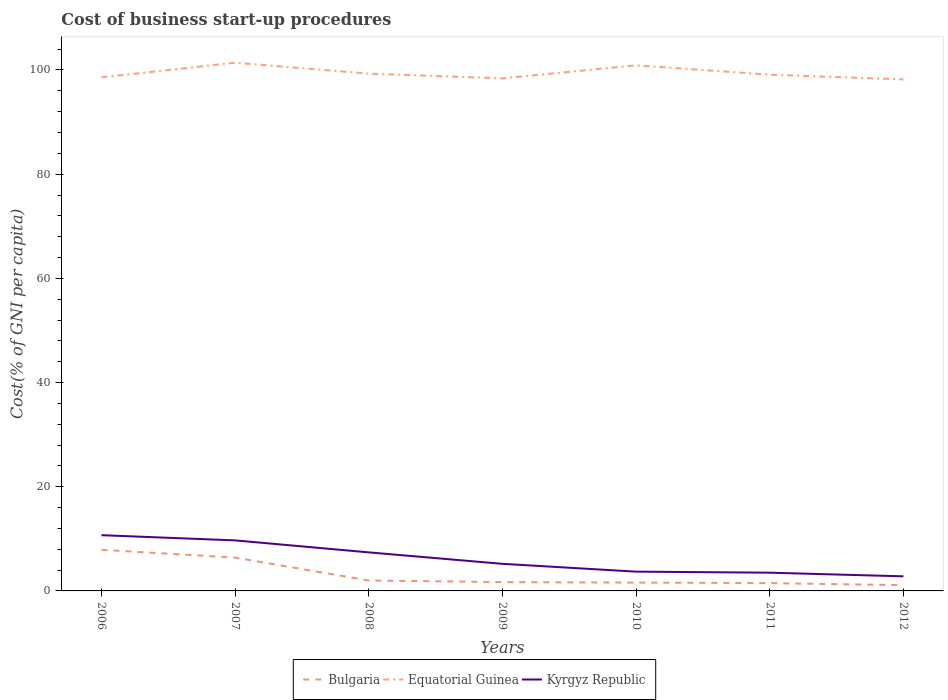How many different coloured lines are there?
Ensure brevity in your answer.  3. Across all years, what is the maximum cost of business start-up procedures in Equatorial Guinea?
Make the answer very short. 98.2. In which year was the cost of business start-up procedures in Kyrgyz Republic maximum?
Keep it short and to the point. 2012. What is the total cost of business start-up procedures in Kyrgyz Republic in the graph?
Give a very brief answer. 1.7. What is the difference between the highest and the second highest cost of business start-up procedures in Bulgaria?
Provide a short and direct response. 6.8. What is the difference between the highest and the lowest cost of business start-up procedures in Equatorial Guinea?
Make the answer very short. 2. Are the values on the major ticks of Y-axis written in scientific E-notation?
Give a very brief answer. No. Where does the legend appear in the graph?
Your answer should be compact. Bottom center. How many legend labels are there?
Offer a terse response. 3. How are the legend labels stacked?
Give a very brief answer. Horizontal. What is the title of the graph?
Keep it short and to the point. Cost of business start-up procedures. Does "Italy" appear as one of the legend labels in the graph?
Your answer should be compact. No. What is the label or title of the X-axis?
Keep it short and to the point. Years. What is the label or title of the Y-axis?
Give a very brief answer. Cost(% of GNI per capita). What is the Cost(% of GNI per capita) in Bulgaria in 2006?
Ensure brevity in your answer.  7.9. What is the Cost(% of GNI per capita) in Equatorial Guinea in 2006?
Keep it short and to the point. 98.6. What is the Cost(% of GNI per capita) in Kyrgyz Republic in 2006?
Keep it short and to the point. 10.7. What is the Cost(% of GNI per capita) of Bulgaria in 2007?
Keep it short and to the point. 6.4. What is the Cost(% of GNI per capita) of Equatorial Guinea in 2007?
Ensure brevity in your answer.  101.4. What is the Cost(% of GNI per capita) of Kyrgyz Republic in 2007?
Offer a terse response. 9.7. What is the Cost(% of GNI per capita) of Bulgaria in 2008?
Keep it short and to the point. 2. What is the Cost(% of GNI per capita) of Equatorial Guinea in 2008?
Make the answer very short. 99.3. What is the Cost(% of GNI per capita) of Bulgaria in 2009?
Your answer should be very brief. 1.7. What is the Cost(% of GNI per capita) of Equatorial Guinea in 2009?
Make the answer very short. 98.4. What is the Cost(% of GNI per capita) of Bulgaria in 2010?
Offer a terse response. 1.6. What is the Cost(% of GNI per capita) of Equatorial Guinea in 2010?
Your answer should be compact. 100.9. What is the Cost(% of GNI per capita) of Equatorial Guinea in 2011?
Your answer should be compact. 99.1. What is the Cost(% of GNI per capita) of Equatorial Guinea in 2012?
Ensure brevity in your answer.  98.2. What is the Cost(% of GNI per capita) in Kyrgyz Republic in 2012?
Provide a succinct answer. 2.8. Across all years, what is the maximum Cost(% of GNI per capita) in Bulgaria?
Provide a succinct answer. 7.9. Across all years, what is the maximum Cost(% of GNI per capita) in Equatorial Guinea?
Offer a very short reply. 101.4. Across all years, what is the maximum Cost(% of GNI per capita) in Kyrgyz Republic?
Ensure brevity in your answer.  10.7. Across all years, what is the minimum Cost(% of GNI per capita) of Equatorial Guinea?
Your answer should be compact. 98.2. What is the total Cost(% of GNI per capita) in Equatorial Guinea in the graph?
Your response must be concise. 695.9. What is the total Cost(% of GNI per capita) in Kyrgyz Republic in the graph?
Ensure brevity in your answer.  43. What is the difference between the Cost(% of GNI per capita) of Equatorial Guinea in 2006 and that in 2007?
Ensure brevity in your answer.  -2.8. What is the difference between the Cost(% of GNI per capita) in Bulgaria in 2006 and that in 2008?
Provide a short and direct response. 5.9. What is the difference between the Cost(% of GNI per capita) in Equatorial Guinea in 2006 and that in 2008?
Ensure brevity in your answer.  -0.7. What is the difference between the Cost(% of GNI per capita) of Kyrgyz Republic in 2006 and that in 2008?
Your answer should be very brief. 3.3. What is the difference between the Cost(% of GNI per capita) of Bulgaria in 2006 and that in 2009?
Offer a terse response. 6.2. What is the difference between the Cost(% of GNI per capita) in Bulgaria in 2006 and that in 2010?
Provide a short and direct response. 6.3. What is the difference between the Cost(% of GNI per capita) in Equatorial Guinea in 2006 and that in 2010?
Offer a terse response. -2.3. What is the difference between the Cost(% of GNI per capita) of Bulgaria in 2006 and that in 2011?
Your answer should be compact. 6.4. What is the difference between the Cost(% of GNI per capita) of Kyrgyz Republic in 2006 and that in 2011?
Provide a succinct answer. 7.2. What is the difference between the Cost(% of GNI per capita) in Bulgaria in 2006 and that in 2012?
Ensure brevity in your answer.  6.8. What is the difference between the Cost(% of GNI per capita) of Equatorial Guinea in 2006 and that in 2012?
Make the answer very short. 0.4. What is the difference between the Cost(% of GNI per capita) of Bulgaria in 2007 and that in 2009?
Provide a short and direct response. 4.7. What is the difference between the Cost(% of GNI per capita) of Equatorial Guinea in 2007 and that in 2009?
Keep it short and to the point. 3. What is the difference between the Cost(% of GNI per capita) in Kyrgyz Republic in 2007 and that in 2009?
Keep it short and to the point. 4.5. What is the difference between the Cost(% of GNI per capita) of Equatorial Guinea in 2007 and that in 2010?
Keep it short and to the point. 0.5. What is the difference between the Cost(% of GNI per capita) in Kyrgyz Republic in 2007 and that in 2010?
Ensure brevity in your answer.  6. What is the difference between the Cost(% of GNI per capita) of Bulgaria in 2008 and that in 2009?
Your answer should be compact. 0.3. What is the difference between the Cost(% of GNI per capita) in Equatorial Guinea in 2008 and that in 2010?
Give a very brief answer. -1.6. What is the difference between the Cost(% of GNI per capita) in Kyrgyz Republic in 2008 and that in 2010?
Your answer should be very brief. 3.7. What is the difference between the Cost(% of GNI per capita) in Equatorial Guinea in 2008 and that in 2012?
Provide a short and direct response. 1.1. What is the difference between the Cost(% of GNI per capita) of Equatorial Guinea in 2009 and that in 2010?
Your answer should be compact. -2.5. What is the difference between the Cost(% of GNI per capita) in Bulgaria in 2009 and that in 2011?
Give a very brief answer. 0.2. What is the difference between the Cost(% of GNI per capita) of Equatorial Guinea in 2009 and that in 2012?
Your answer should be compact. 0.2. What is the difference between the Cost(% of GNI per capita) of Equatorial Guinea in 2010 and that in 2011?
Provide a short and direct response. 1.8. What is the difference between the Cost(% of GNI per capita) of Bulgaria in 2010 and that in 2012?
Give a very brief answer. 0.5. What is the difference between the Cost(% of GNI per capita) in Equatorial Guinea in 2010 and that in 2012?
Keep it short and to the point. 2.7. What is the difference between the Cost(% of GNI per capita) in Kyrgyz Republic in 2011 and that in 2012?
Make the answer very short. 0.7. What is the difference between the Cost(% of GNI per capita) of Bulgaria in 2006 and the Cost(% of GNI per capita) of Equatorial Guinea in 2007?
Your answer should be very brief. -93.5. What is the difference between the Cost(% of GNI per capita) of Bulgaria in 2006 and the Cost(% of GNI per capita) of Kyrgyz Republic in 2007?
Make the answer very short. -1.8. What is the difference between the Cost(% of GNI per capita) of Equatorial Guinea in 2006 and the Cost(% of GNI per capita) of Kyrgyz Republic in 2007?
Offer a terse response. 88.9. What is the difference between the Cost(% of GNI per capita) of Bulgaria in 2006 and the Cost(% of GNI per capita) of Equatorial Guinea in 2008?
Provide a short and direct response. -91.4. What is the difference between the Cost(% of GNI per capita) in Bulgaria in 2006 and the Cost(% of GNI per capita) in Kyrgyz Republic in 2008?
Make the answer very short. 0.5. What is the difference between the Cost(% of GNI per capita) in Equatorial Guinea in 2006 and the Cost(% of GNI per capita) in Kyrgyz Republic in 2008?
Offer a very short reply. 91.2. What is the difference between the Cost(% of GNI per capita) in Bulgaria in 2006 and the Cost(% of GNI per capita) in Equatorial Guinea in 2009?
Provide a short and direct response. -90.5. What is the difference between the Cost(% of GNI per capita) of Equatorial Guinea in 2006 and the Cost(% of GNI per capita) of Kyrgyz Republic in 2009?
Your response must be concise. 93.4. What is the difference between the Cost(% of GNI per capita) of Bulgaria in 2006 and the Cost(% of GNI per capita) of Equatorial Guinea in 2010?
Provide a succinct answer. -93. What is the difference between the Cost(% of GNI per capita) of Bulgaria in 2006 and the Cost(% of GNI per capita) of Kyrgyz Republic in 2010?
Keep it short and to the point. 4.2. What is the difference between the Cost(% of GNI per capita) of Equatorial Guinea in 2006 and the Cost(% of GNI per capita) of Kyrgyz Republic in 2010?
Offer a terse response. 94.9. What is the difference between the Cost(% of GNI per capita) in Bulgaria in 2006 and the Cost(% of GNI per capita) in Equatorial Guinea in 2011?
Your answer should be compact. -91.2. What is the difference between the Cost(% of GNI per capita) of Bulgaria in 2006 and the Cost(% of GNI per capita) of Kyrgyz Republic in 2011?
Provide a short and direct response. 4.4. What is the difference between the Cost(% of GNI per capita) of Equatorial Guinea in 2006 and the Cost(% of GNI per capita) of Kyrgyz Republic in 2011?
Your answer should be compact. 95.1. What is the difference between the Cost(% of GNI per capita) in Bulgaria in 2006 and the Cost(% of GNI per capita) in Equatorial Guinea in 2012?
Provide a succinct answer. -90.3. What is the difference between the Cost(% of GNI per capita) in Bulgaria in 2006 and the Cost(% of GNI per capita) in Kyrgyz Republic in 2012?
Make the answer very short. 5.1. What is the difference between the Cost(% of GNI per capita) of Equatorial Guinea in 2006 and the Cost(% of GNI per capita) of Kyrgyz Republic in 2012?
Ensure brevity in your answer.  95.8. What is the difference between the Cost(% of GNI per capita) in Bulgaria in 2007 and the Cost(% of GNI per capita) in Equatorial Guinea in 2008?
Your response must be concise. -92.9. What is the difference between the Cost(% of GNI per capita) of Equatorial Guinea in 2007 and the Cost(% of GNI per capita) of Kyrgyz Republic in 2008?
Offer a terse response. 94. What is the difference between the Cost(% of GNI per capita) in Bulgaria in 2007 and the Cost(% of GNI per capita) in Equatorial Guinea in 2009?
Your answer should be compact. -92. What is the difference between the Cost(% of GNI per capita) of Bulgaria in 2007 and the Cost(% of GNI per capita) of Kyrgyz Republic in 2009?
Offer a terse response. 1.2. What is the difference between the Cost(% of GNI per capita) in Equatorial Guinea in 2007 and the Cost(% of GNI per capita) in Kyrgyz Republic in 2009?
Provide a succinct answer. 96.2. What is the difference between the Cost(% of GNI per capita) in Bulgaria in 2007 and the Cost(% of GNI per capita) in Equatorial Guinea in 2010?
Give a very brief answer. -94.5. What is the difference between the Cost(% of GNI per capita) of Equatorial Guinea in 2007 and the Cost(% of GNI per capita) of Kyrgyz Republic in 2010?
Your answer should be compact. 97.7. What is the difference between the Cost(% of GNI per capita) in Bulgaria in 2007 and the Cost(% of GNI per capita) in Equatorial Guinea in 2011?
Your response must be concise. -92.7. What is the difference between the Cost(% of GNI per capita) of Bulgaria in 2007 and the Cost(% of GNI per capita) of Kyrgyz Republic in 2011?
Keep it short and to the point. 2.9. What is the difference between the Cost(% of GNI per capita) in Equatorial Guinea in 2007 and the Cost(% of GNI per capita) in Kyrgyz Republic in 2011?
Give a very brief answer. 97.9. What is the difference between the Cost(% of GNI per capita) of Bulgaria in 2007 and the Cost(% of GNI per capita) of Equatorial Guinea in 2012?
Provide a short and direct response. -91.8. What is the difference between the Cost(% of GNI per capita) in Equatorial Guinea in 2007 and the Cost(% of GNI per capita) in Kyrgyz Republic in 2012?
Ensure brevity in your answer.  98.6. What is the difference between the Cost(% of GNI per capita) in Bulgaria in 2008 and the Cost(% of GNI per capita) in Equatorial Guinea in 2009?
Provide a succinct answer. -96.4. What is the difference between the Cost(% of GNI per capita) in Equatorial Guinea in 2008 and the Cost(% of GNI per capita) in Kyrgyz Republic in 2009?
Make the answer very short. 94.1. What is the difference between the Cost(% of GNI per capita) of Bulgaria in 2008 and the Cost(% of GNI per capita) of Equatorial Guinea in 2010?
Make the answer very short. -98.9. What is the difference between the Cost(% of GNI per capita) of Bulgaria in 2008 and the Cost(% of GNI per capita) of Kyrgyz Republic in 2010?
Offer a very short reply. -1.7. What is the difference between the Cost(% of GNI per capita) of Equatorial Guinea in 2008 and the Cost(% of GNI per capita) of Kyrgyz Republic in 2010?
Your response must be concise. 95.6. What is the difference between the Cost(% of GNI per capita) in Bulgaria in 2008 and the Cost(% of GNI per capita) in Equatorial Guinea in 2011?
Provide a succinct answer. -97.1. What is the difference between the Cost(% of GNI per capita) in Bulgaria in 2008 and the Cost(% of GNI per capita) in Kyrgyz Republic in 2011?
Keep it short and to the point. -1.5. What is the difference between the Cost(% of GNI per capita) of Equatorial Guinea in 2008 and the Cost(% of GNI per capita) of Kyrgyz Republic in 2011?
Make the answer very short. 95.8. What is the difference between the Cost(% of GNI per capita) in Bulgaria in 2008 and the Cost(% of GNI per capita) in Equatorial Guinea in 2012?
Your response must be concise. -96.2. What is the difference between the Cost(% of GNI per capita) of Bulgaria in 2008 and the Cost(% of GNI per capita) of Kyrgyz Republic in 2012?
Make the answer very short. -0.8. What is the difference between the Cost(% of GNI per capita) of Equatorial Guinea in 2008 and the Cost(% of GNI per capita) of Kyrgyz Republic in 2012?
Offer a terse response. 96.5. What is the difference between the Cost(% of GNI per capita) in Bulgaria in 2009 and the Cost(% of GNI per capita) in Equatorial Guinea in 2010?
Ensure brevity in your answer.  -99.2. What is the difference between the Cost(% of GNI per capita) of Bulgaria in 2009 and the Cost(% of GNI per capita) of Kyrgyz Republic in 2010?
Your answer should be compact. -2. What is the difference between the Cost(% of GNI per capita) in Equatorial Guinea in 2009 and the Cost(% of GNI per capita) in Kyrgyz Republic in 2010?
Provide a short and direct response. 94.7. What is the difference between the Cost(% of GNI per capita) in Bulgaria in 2009 and the Cost(% of GNI per capita) in Equatorial Guinea in 2011?
Your answer should be very brief. -97.4. What is the difference between the Cost(% of GNI per capita) of Bulgaria in 2009 and the Cost(% of GNI per capita) of Kyrgyz Republic in 2011?
Your answer should be compact. -1.8. What is the difference between the Cost(% of GNI per capita) in Equatorial Guinea in 2009 and the Cost(% of GNI per capita) in Kyrgyz Republic in 2011?
Provide a succinct answer. 94.9. What is the difference between the Cost(% of GNI per capita) of Bulgaria in 2009 and the Cost(% of GNI per capita) of Equatorial Guinea in 2012?
Your response must be concise. -96.5. What is the difference between the Cost(% of GNI per capita) of Bulgaria in 2009 and the Cost(% of GNI per capita) of Kyrgyz Republic in 2012?
Your answer should be very brief. -1.1. What is the difference between the Cost(% of GNI per capita) in Equatorial Guinea in 2009 and the Cost(% of GNI per capita) in Kyrgyz Republic in 2012?
Your response must be concise. 95.6. What is the difference between the Cost(% of GNI per capita) in Bulgaria in 2010 and the Cost(% of GNI per capita) in Equatorial Guinea in 2011?
Offer a very short reply. -97.5. What is the difference between the Cost(% of GNI per capita) of Bulgaria in 2010 and the Cost(% of GNI per capita) of Kyrgyz Republic in 2011?
Make the answer very short. -1.9. What is the difference between the Cost(% of GNI per capita) of Equatorial Guinea in 2010 and the Cost(% of GNI per capita) of Kyrgyz Republic in 2011?
Your answer should be very brief. 97.4. What is the difference between the Cost(% of GNI per capita) in Bulgaria in 2010 and the Cost(% of GNI per capita) in Equatorial Guinea in 2012?
Your answer should be compact. -96.6. What is the difference between the Cost(% of GNI per capita) in Bulgaria in 2010 and the Cost(% of GNI per capita) in Kyrgyz Republic in 2012?
Make the answer very short. -1.2. What is the difference between the Cost(% of GNI per capita) in Equatorial Guinea in 2010 and the Cost(% of GNI per capita) in Kyrgyz Republic in 2012?
Your answer should be compact. 98.1. What is the difference between the Cost(% of GNI per capita) in Bulgaria in 2011 and the Cost(% of GNI per capita) in Equatorial Guinea in 2012?
Your response must be concise. -96.7. What is the difference between the Cost(% of GNI per capita) in Bulgaria in 2011 and the Cost(% of GNI per capita) in Kyrgyz Republic in 2012?
Make the answer very short. -1.3. What is the difference between the Cost(% of GNI per capita) in Equatorial Guinea in 2011 and the Cost(% of GNI per capita) in Kyrgyz Republic in 2012?
Give a very brief answer. 96.3. What is the average Cost(% of GNI per capita) in Bulgaria per year?
Provide a succinct answer. 3.17. What is the average Cost(% of GNI per capita) of Equatorial Guinea per year?
Offer a terse response. 99.41. What is the average Cost(% of GNI per capita) of Kyrgyz Republic per year?
Your answer should be very brief. 6.14. In the year 2006, what is the difference between the Cost(% of GNI per capita) of Bulgaria and Cost(% of GNI per capita) of Equatorial Guinea?
Your response must be concise. -90.7. In the year 2006, what is the difference between the Cost(% of GNI per capita) in Bulgaria and Cost(% of GNI per capita) in Kyrgyz Republic?
Make the answer very short. -2.8. In the year 2006, what is the difference between the Cost(% of GNI per capita) of Equatorial Guinea and Cost(% of GNI per capita) of Kyrgyz Republic?
Keep it short and to the point. 87.9. In the year 2007, what is the difference between the Cost(% of GNI per capita) in Bulgaria and Cost(% of GNI per capita) in Equatorial Guinea?
Keep it short and to the point. -95. In the year 2007, what is the difference between the Cost(% of GNI per capita) in Bulgaria and Cost(% of GNI per capita) in Kyrgyz Republic?
Offer a terse response. -3.3. In the year 2007, what is the difference between the Cost(% of GNI per capita) in Equatorial Guinea and Cost(% of GNI per capita) in Kyrgyz Republic?
Offer a very short reply. 91.7. In the year 2008, what is the difference between the Cost(% of GNI per capita) in Bulgaria and Cost(% of GNI per capita) in Equatorial Guinea?
Ensure brevity in your answer.  -97.3. In the year 2008, what is the difference between the Cost(% of GNI per capita) in Equatorial Guinea and Cost(% of GNI per capita) in Kyrgyz Republic?
Ensure brevity in your answer.  91.9. In the year 2009, what is the difference between the Cost(% of GNI per capita) in Bulgaria and Cost(% of GNI per capita) in Equatorial Guinea?
Your answer should be compact. -96.7. In the year 2009, what is the difference between the Cost(% of GNI per capita) of Equatorial Guinea and Cost(% of GNI per capita) of Kyrgyz Republic?
Provide a succinct answer. 93.2. In the year 2010, what is the difference between the Cost(% of GNI per capita) in Bulgaria and Cost(% of GNI per capita) in Equatorial Guinea?
Your answer should be very brief. -99.3. In the year 2010, what is the difference between the Cost(% of GNI per capita) in Bulgaria and Cost(% of GNI per capita) in Kyrgyz Republic?
Your answer should be very brief. -2.1. In the year 2010, what is the difference between the Cost(% of GNI per capita) in Equatorial Guinea and Cost(% of GNI per capita) in Kyrgyz Republic?
Provide a short and direct response. 97.2. In the year 2011, what is the difference between the Cost(% of GNI per capita) of Bulgaria and Cost(% of GNI per capita) of Equatorial Guinea?
Give a very brief answer. -97.6. In the year 2011, what is the difference between the Cost(% of GNI per capita) of Bulgaria and Cost(% of GNI per capita) of Kyrgyz Republic?
Keep it short and to the point. -2. In the year 2011, what is the difference between the Cost(% of GNI per capita) of Equatorial Guinea and Cost(% of GNI per capita) of Kyrgyz Republic?
Offer a terse response. 95.6. In the year 2012, what is the difference between the Cost(% of GNI per capita) of Bulgaria and Cost(% of GNI per capita) of Equatorial Guinea?
Make the answer very short. -97.1. In the year 2012, what is the difference between the Cost(% of GNI per capita) in Equatorial Guinea and Cost(% of GNI per capita) in Kyrgyz Republic?
Keep it short and to the point. 95.4. What is the ratio of the Cost(% of GNI per capita) in Bulgaria in 2006 to that in 2007?
Ensure brevity in your answer.  1.23. What is the ratio of the Cost(% of GNI per capita) of Equatorial Guinea in 2006 to that in 2007?
Offer a very short reply. 0.97. What is the ratio of the Cost(% of GNI per capita) of Kyrgyz Republic in 2006 to that in 2007?
Ensure brevity in your answer.  1.1. What is the ratio of the Cost(% of GNI per capita) of Bulgaria in 2006 to that in 2008?
Your response must be concise. 3.95. What is the ratio of the Cost(% of GNI per capita) in Equatorial Guinea in 2006 to that in 2008?
Offer a terse response. 0.99. What is the ratio of the Cost(% of GNI per capita) in Kyrgyz Republic in 2006 to that in 2008?
Provide a short and direct response. 1.45. What is the ratio of the Cost(% of GNI per capita) of Bulgaria in 2006 to that in 2009?
Give a very brief answer. 4.65. What is the ratio of the Cost(% of GNI per capita) of Kyrgyz Republic in 2006 to that in 2009?
Your response must be concise. 2.06. What is the ratio of the Cost(% of GNI per capita) in Bulgaria in 2006 to that in 2010?
Ensure brevity in your answer.  4.94. What is the ratio of the Cost(% of GNI per capita) in Equatorial Guinea in 2006 to that in 2010?
Give a very brief answer. 0.98. What is the ratio of the Cost(% of GNI per capita) in Kyrgyz Republic in 2006 to that in 2010?
Provide a short and direct response. 2.89. What is the ratio of the Cost(% of GNI per capita) of Bulgaria in 2006 to that in 2011?
Make the answer very short. 5.27. What is the ratio of the Cost(% of GNI per capita) of Equatorial Guinea in 2006 to that in 2011?
Make the answer very short. 0.99. What is the ratio of the Cost(% of GNI per capita) in Kyrgyz Republic in 2006 to that in 2011?
Your response must be concise. 3.06. What is the ratio of the Cost(% of GNI per capita) in Bulgaria in 2006 to that in 2012?
Ensure brevity in your answer.  7.18. What is the ratio of the Cost(% of GNI per capita) of Kyrgyz Republic in 2006 to that in 2012?
Ensure brevity in your answer.  3.82. What is the ratio of the Cost(% of GNI per capita) of Equatorial Guinea in 2007 to that in 2008?
Ensure brevity in your answer.  1.02. What is the ratio of the Cost(% of GNI per capita) in Kyrgyz Republic in 2007 to that in 2008?
Ensure brevity in your answer.  1.31. What is the ratio of the Cost(% of GNI per capita) in Bulgaria in 2007 to that in 2009?
Provide a short and direct response. 3.76. What is the ratio of the Cost(% of GNI per capita) in Equatorial Guinea in 2007 to that in 2009?
Offer a terse response. 1.03. What is the ratio of the Cost(% of GNI per capita) of Kyrgyz Republic in 2007 to that in 2009?
Offer a terse response. 1.87. What is the ratio of the Cost(% of GNI per capita) in Equatorial Guinea in 2007 to that in 2010?
Make the answer very short. 1. What is the ratio of the Cost(% of GNI per capita) in Kyrgyz Republic in 2007 to that in 2010?
Keep it short and to the point. 2.62. What is the ratio of the Cost(% of GNI per capita) of Bulgaria in 2007 to that in 2011?
Offer a very short reply. 4.27. What is the ratio of the Cost(% of GNI per capita) of Equatorial Guinea in 2007 to that in 2011?
Make the answer very short. 1.02. What is the ratio of the Cost(% of GNI per capita) of Kyrgyz Republic in 2007 to that in 2011?
Give a very brief answer. 2.77. What is the ratio of the Cost(% of GNI per capita) in Bulgaria in 2007 to that in 2012?
Your answer should be compact. 5.82. What is the ratio of the Cost(% of GNI per capita) of Equatorial Guinea in 2007 to that in 2012?
Offer a terse response. 1.03. What is the ratio of the Cost(% of GNI per capita) in Kyrgyz Republic in 2007 to that in 2012?
Keep it short and to the point. 3.46. What is the ratio of the Cost(% of GNI per capita) in Bulgaria in 2008 to that in 2009?
Provide a succinct answer. 1.18. What is the ratio of the Cost(% of GNI per capita) of Equatorial Guinea in 2008 to that in 2009?
Ensure brevity in your answer.  1.01. What is the ratio of the Cost(% of GNI per capita) of Kyrgyz Republic in 2008 to that in 2009?
Provide a succinct answer. 1.42. What is the ratio of the Cost(% of GNI per capita) of Bulgaria in 2008 to that in 2010?
Make the answer very short. 1.25. What is the ratio of the Cost(% of GNI per capita) in Equatorial Guinea in 2008 to that in 2010?
Offer a very short reply. 0.98. What is the ratio of the Cost(% of GNI per capita) in Kyrgyz Republic in 2008 to that in 2010?
Ensure brevity in your answer.  2. What is the ratio of the Cost(% of GNI per capita) in Equatorial Guinea in 2008 to that in 2011?
Your answer should be compact. 1. What is the ratio of the Cost(% of GNI per capita) in Kyrgyz Republic in 2008 to that in 2011?
Offer a terse response. 2.11. What is the ratio of the Cost(% of GNI per capita) in Bulgaria in 2008 to that in 2012?
Give a very brief answer. 1.82. What is the ratio of the Cost(% of GNI per capita) of Equatorial Guinea in 2008 to that in 2012?
Your response must be concise. 1.01. What is the ratio of the Cost(% of GNI per capita) in Kyrgyz Republic in 2008 to that in 2012?
Provide a short and direct response. 2.64. What is the ratio of the Cost(% of GNI per capita) of Equatorial Guinea in 2009 to that in 2010?
Your answer should be very brief. 0.98. What is the ratio of the Cost(% of GNI per capita) of Kyrgyz Republic in 2009 to that in 2010?
Make the answer very short. 1.41. What is the ratio of the Cost(% of GNI per capita) of Bulgaria in 2009 to that in 2011?
Provide a short and direct response. 1.13. What is the ratio of the Cost(% of GNI per capita) in Equatorial Guinea in 2009 to that in 2011?
Provide a succinct answer. 0.99. What is the ratio of the Cost(% of GNI per capita) of Kyrgyz Republic in 2009 to that in 2011?
Your response must be concise. 1.49. What is the ratio of the Cost(% of GNI per capita) in Bulgaria in 2009 to that in 2012?
Your answer should be compact. 1.55. What is the ratio of the Cost(% of GNI per capita) in Kyrgyz Republic in 2009 to that in 2012?
Provide a short and direct response. 1.86. What is the ratio of the Cost(% of GNI per capita) of Bulgaria in 2010 to that in 2011?
Your answer should be compact. 1.07. What is the ratio of the Cost(% of GNI per capita) of Equatorial Guinea in 2010 to that in 2011?
Offer a very short reply. 1.02. What is the ratio of the Cost(% of GNI per capita) of Kyrgyz Republic in 2010 to that in 2011?
Make the answer very short. 1.06. What is the ratio of the Cost(% of GNI per capita) of Bulgaria in 2010 to that in 2012?
Give a very brief answer. 1.45. What is the ratio of the Cost(% of GNI per capita) of Equatorial Guinea in 2010 to that in 2012?
Keep it short and to the point. 1.03. What is the ratio of the Cost(% of GNI per capita) of Kyrgyz Republic in 2010 to that in 2012?
Give a very brief answer. 1.32. What is the ratio of the Cost(% of GNI per capita) of Bulgaria in 2011 to that in 2012?
Provide a succinct answer. 1.36. What is the ratio of the Cost(% of GNI per capita) in Equatorial Guinea in 2011 to that in 2012?
Provide a short and direct response. 1.01. What is the difference between the highest and the second highest Cost(% of GNI per capita) in Bulgaria?
Ensure brevity in your answer.  1.5. What is the difference between the highest and the second highest Cost(% of GNI per capita) in Kyrgyz Republic?
Your answer should be compact. 1. 